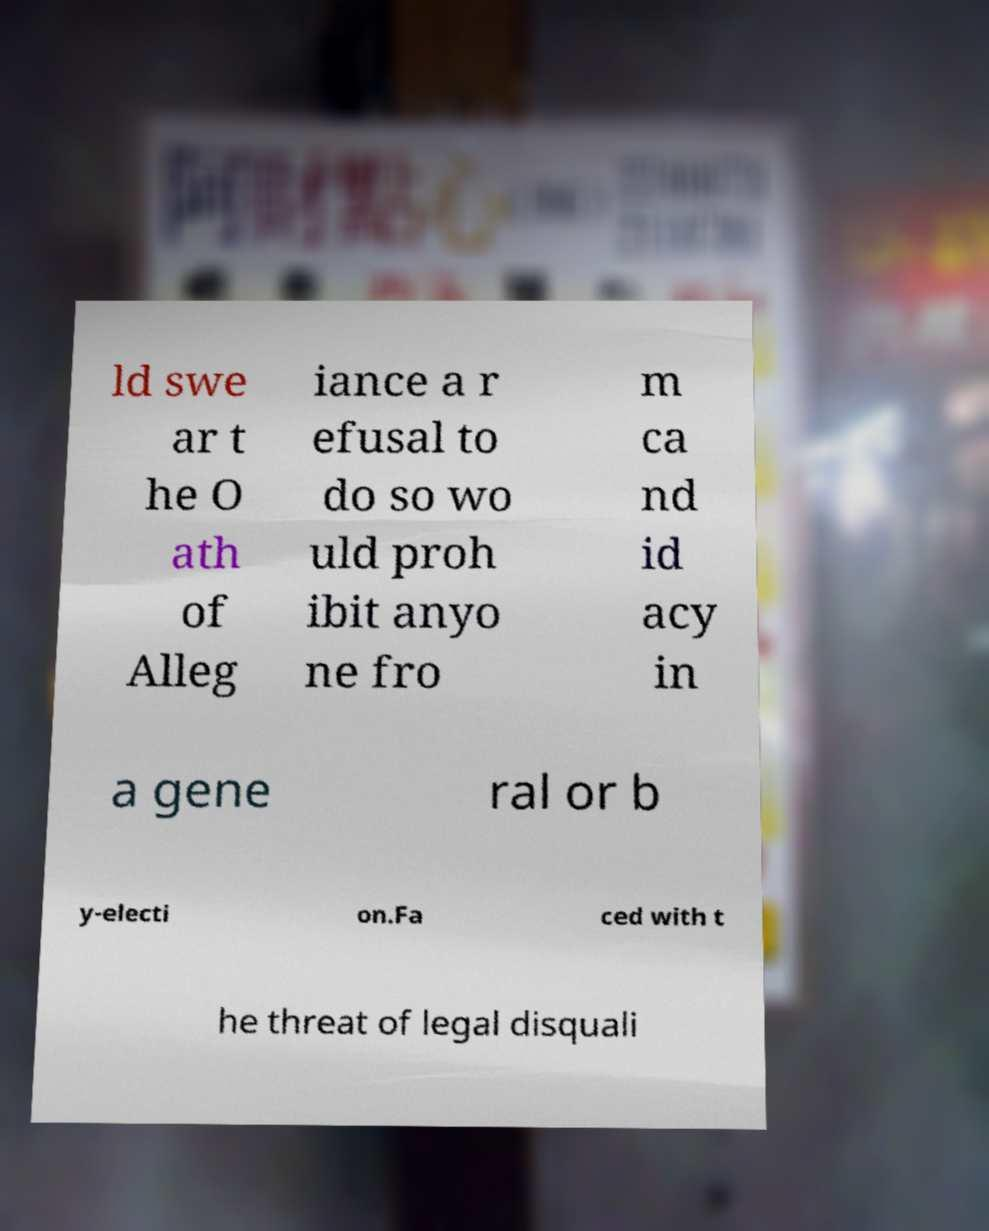There's text embedded in this image that I need extracted. Can you transcribe it verbatim? ld swe ar t he O ath of Alleg iance a r efusal to do so wo uld proh ibit anyo ne fro m ca nd id acy in a gene ral or b y-electi on.Fa ced with t he threat of legal disquali 